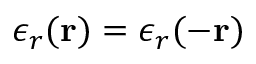Convert formula to latex. <formula><loc_0><loc_0><loc_500><loc_500>\epsilon _ { r } ( r ) = \epsilon _ { r } ( - r )</formula> 